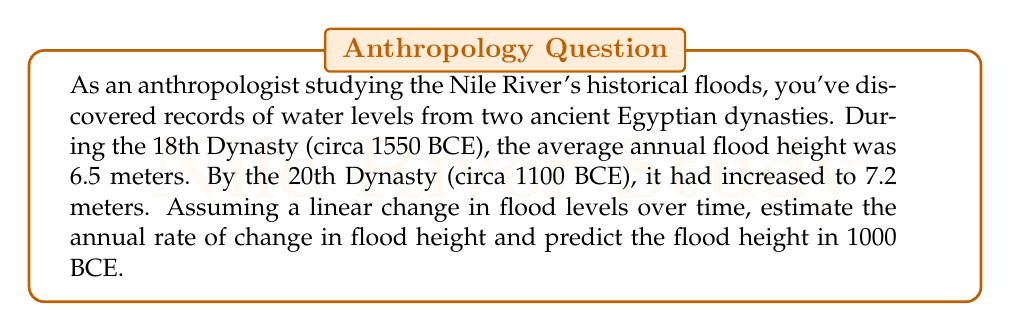Show me your answer to this math problem. Let's approach this problem step-by-step using a linear equation:

1) First, we need to set up our variables:
   Let $x$ represent the number of years since 1550 BCE
   Let $y$ represent the flood height in meters

2) We can write our linear equation in the form $y = mx + b$, where:
   $m$ is the slope (annual rate of change)
   $b$ is the y-intercept (initial flood height in 1550 BCE)

3) We know two points on this line:
   (0, 6.5) for 1550 BCE
   (450, 7.2) for 1100 BCE (450 years after 1550 BCE)

4) We can calculate the slope (m) using the point-slope formula:
   $m = \frac{y_2 - y_1}{x_2 - x_1} = \frac{7.2 - 6.5}{450 - 0} = \frac{0.7}{450} \approx 0.00156$ meters/year

5) Now we can form our equation:
   $y = 0.00156x + 6.5$

6) To predict the flood height in 1000 BCE, we need to calculate $x$:
   1000 BCE is 550 years after 1550 BCE, so $x = 550$

7) Plug this into our equation:
   $y = 0.00156(550) + 6.5 = 0.858 + 6.5 = 7.358$ meters

Therefore, the predicted flood height in 1000 BCE is approximately 7.36 meters.
Answer: The annual rate of change in flood height is approximately 0.00156 meters per year, and the predicted flood height in 1000 BCE is approximately 7.36 meters. 